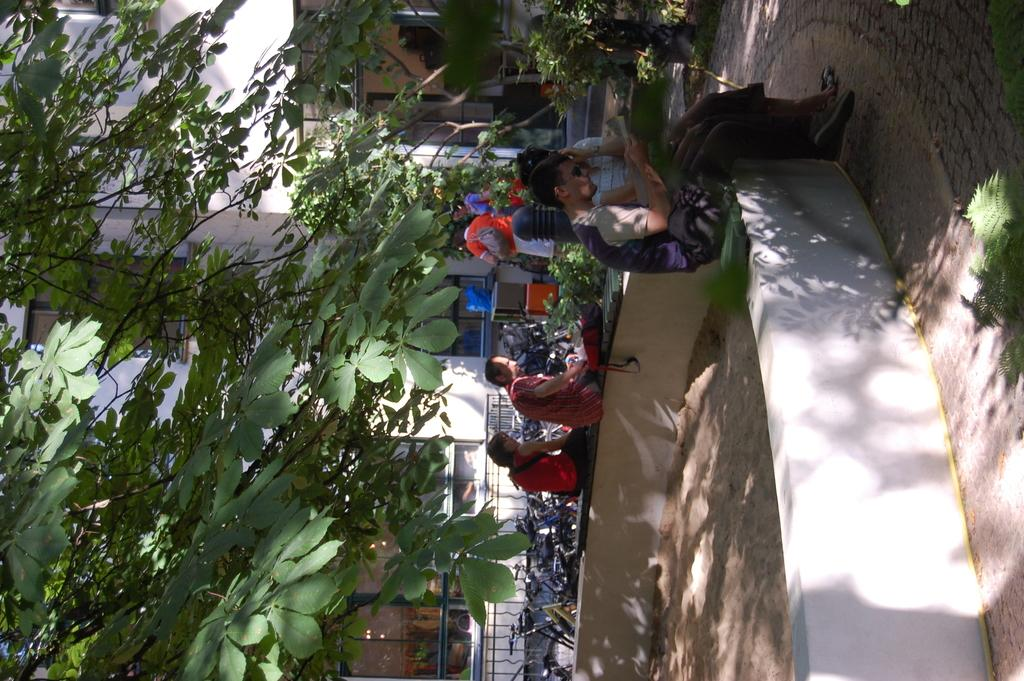What are the people in the image doing? The people in the image are sitting. What can be seen in the background of the image? There are trees, vehicles, buildings, and glass windows in the background of the image. What type of stitch is being used to repair the calculator in the image? There is no calculator or stitching activity present in the image. 